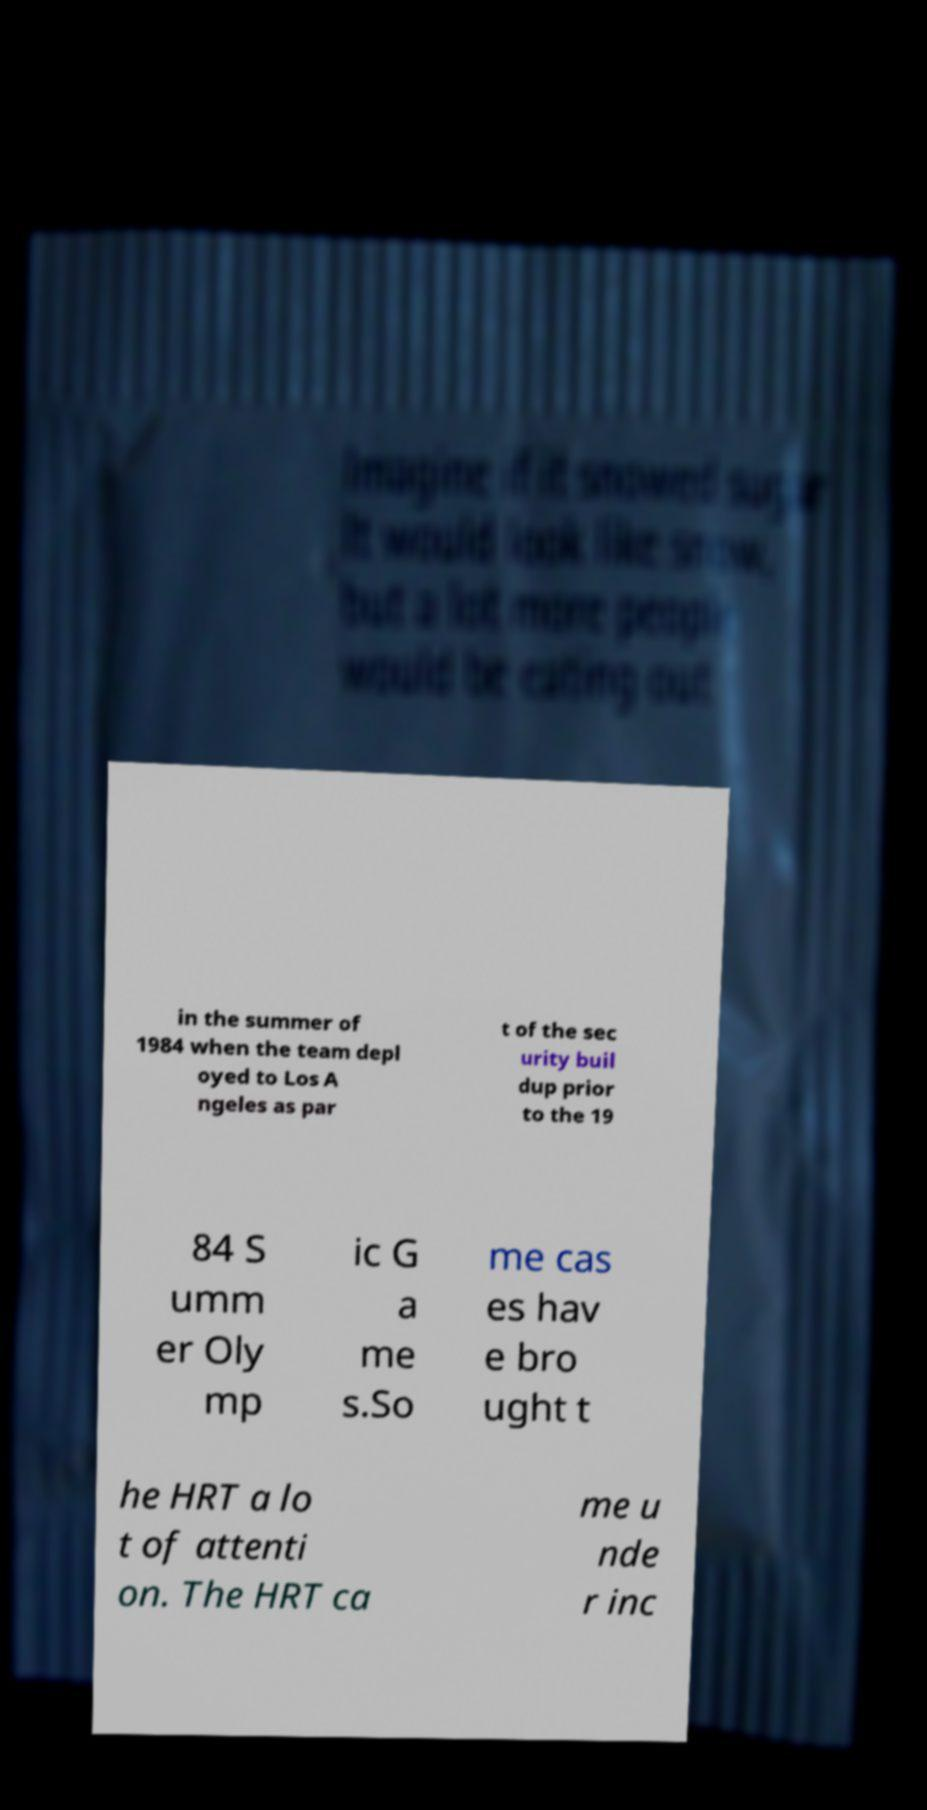What messages or text are displayed in this image? I need them in a readable, typed format. in the summer of 1984 when the team depl oyed to Los A ngeles as par t of the sec urity buil dup prior to the 19 84 S umm er Oly mp ic G a me s.So me cas es hav e bro ught t he HRT a lo t of attenti on. The HRT ca me u nde r inc 